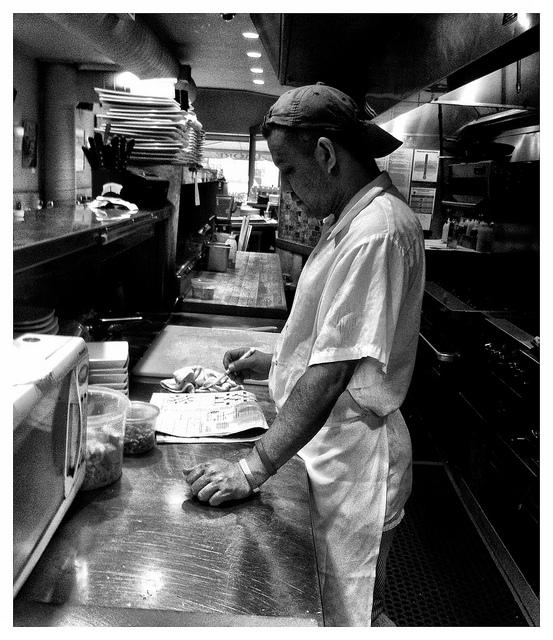How many armbands is the man wearing?
Short answer required. 2. What is this man's job?
Give a very brief answer. Cook. Is this picture in color?
Write a very short answer. No. 